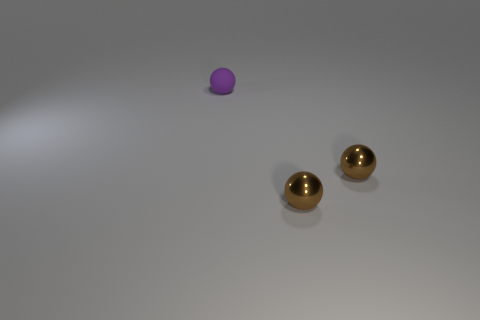Add 2 small purple matte spheres. How many objects exist? 5 Subtract 0 blue spheres. How many objects are left? 3 Subtract all brown metal spheres. Subtract all tiny purple objects. How many objects are left? 0 Add 3 purple balls. How many purple balls are left? 4 Add 3 tiny metal cylinders. How many tiny metal cylinders exist? 3 